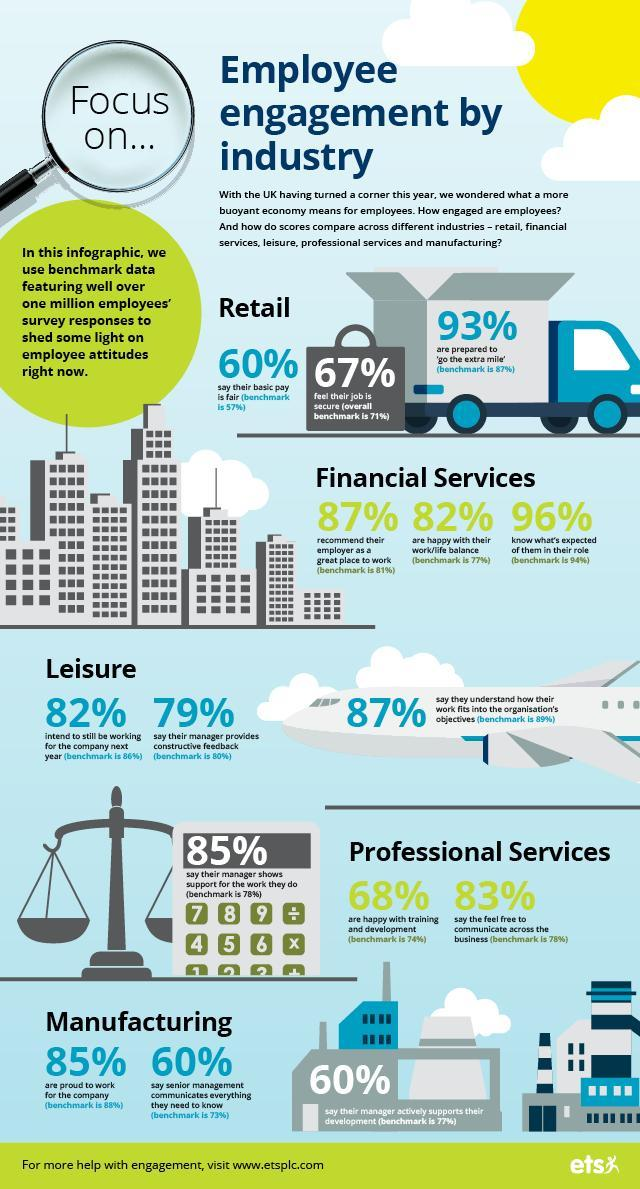What percentage of UK employees in financial services know what's expected of them in their role according to the survey?
Answer the question with a short phrase. 96% What percentage of UK employees in manufacturing industry are proud to work for the company as per the survey? 85% What percentage of UK employees in retail services feel that their job is not secure? 33% What percentage of UK employees in manufacturing industry say that their manager don't actively supports their development according to the survey? 40% What percentage of UK employees in financial services do not recommend their employer as a great place to work according to the survey? 13% What percentage of UK employees in financial services are happy with their work/life balance according to the survey? 82% 